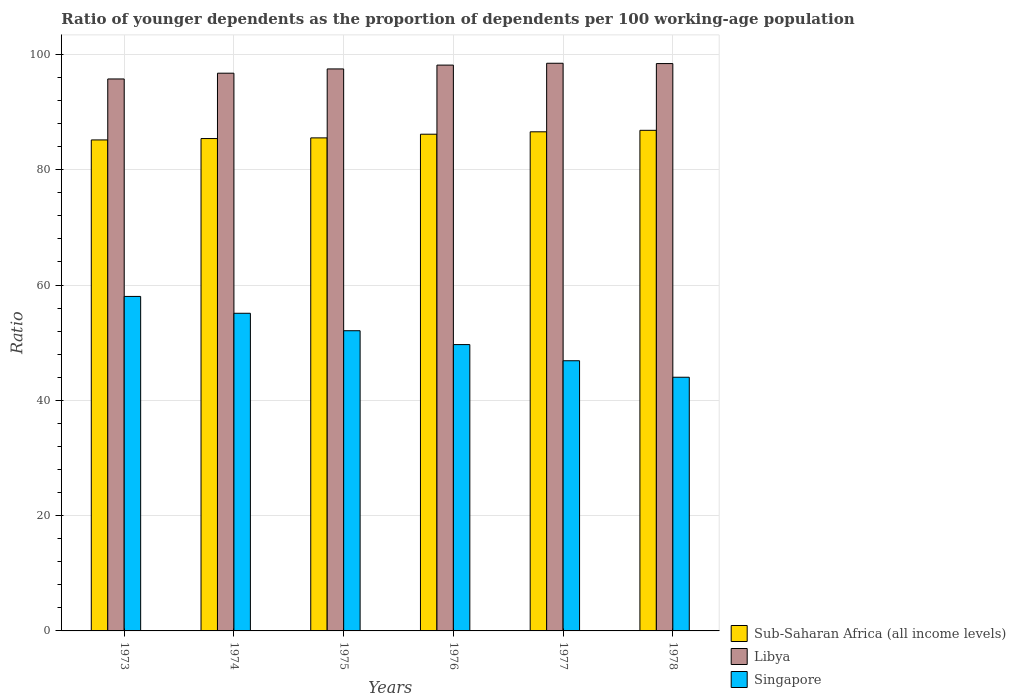How many groups of bars are there?
Offer a terse response. 6. Are the number of bars on each tick of the X-axis equal?
Your answer should be compact. Yes. How many bars are there on the 2nd tick from the left?
Your answer should be compact. 3. What is the label of the 2nd group of bars from the left?
Offer a terse response. 1974. In how many cases, is the number of bars for a given year not equal to the number of legend labels?
Ensure brevity in your answer.  0. What is the age dependency ratio(young) in Sub-Saharan Africa (all income levels) in 1976?
Offer a very short reply. 86.16. Across all years, what is the maximum age dependency ratio(young) in Sub-Saharan Africa (all income levels)?
Ensure brevity in your answer.  86.83. Across all years, what is the minimum age dependency ratio(young) in Libya?
Provide a short and direct response. 95.74. In which year was the age dependency ratio(young) in Sub-Saharan Africa (all income levels) maximum?
Provide a short and direct response. 1978. In which year was the age dependency ratio(young) in Singapore minimum?
Offer a very short reply. 1978. What is the total age dependency ratio(young) in Sub-Saharan Africa (all income levels) in the graph?
Offer a very short reply. 515.66. What is the difference between the age dependency ratio(young) in Libya in 1977 and that in 1978?
Your answer should be compact. 0.05. What is the difference between the age dependency ratio(young) in Libya in 1977 and the age dependency ratio(young) in Sub-Saharan Africa (all income levels) in 1975?
Your answer should be compact. 12.95. What is the average age dependency ratio(young) in Libya per year?
Keep it short and to the point. 97.5. In the year 1976, what is the difference between the age dependency ratio(young) in Singapore and age dependency ratio(young) in Libya?
Provide a short and direct response. -48.48. In how many years, is the age dependency ratio(young) in Singapore greater than 92?
Give a very brief answer. 0. What is the ratio of the age dependency ratio(young) in Singapore in 1977 to that in 1978?
Offer a very short reply. 1.07. What is the difference between the highest and the second highest age dependency ratio(young) in Sub-Saharan Africa (all income levels)?
Give a very brief answer. 0.26. What is the difference between the highest and the lowest age dependency ratio(young) in Sub-Saharan Africa (all income levels)?
Provide a short and direct response. 1.67. What does the 3rd bar from the left in 1973 represents?
Keep it short and to the point. Singapore. What does the 1st bar from the right in 1973 represents?
Your answer should be compact. Singapore. How many bars are there?
Give a very brief answer. 18. Are all the bars in the graph horizontal?
Offer a very short reply. No. How many years are there in the graph?
Your response must be concise. 6. Are the values on the major ticks of Y-axis written in scientific E-notation?
Give a very brief answer. No. Does the graph contain grids?
Your response must be concise. Yes. How many legend labels are there?
Make the answer very short. 3. How are the legend labels stacked?
Keep it short and to the point. Vertical. What is the title of the graph?
Your response must be concise. Ratio of younger dependents as the proportion of dependents per 100 working-age population. Does "Israel" appear as one of the legend labels in the graph?
Make the answer very short. No. What is the label or title of the Y-axis?
Your answer should be compact. Ratio. What is the Ratio in Sub-Saharan Africa (all income levels) in 1973?
Offer a very short reply. 85.17. What is the Ratio in Libya in 1973?
Make the answer very short. 95.74. What is the Ratio of Singapore in 1973?
Provide a succinct answer. 58.02. What is the Ratio of Sub-Saharan Africa (all income levels) in 1974?
Ensure brevity in your answer.  85.41. What is the Ratio of Libya in 1974?
Offer a very short reply. 96.74. What is the Ratio of Singapore in 1974?
Provide a short and direct response. 55.1. What is the Ratio in Sub-Saharan Africa (all income levels) in 1975?
Give a very brief answer. 85.52. What is the Ratio in Libya in 1975?
Provide a succinct answer. 97.48. What is the Ratio of Singapore in 1975?
Your response must be concise. 52.07. What is the Ratio of Sub-Saharan Africa (all income levels) in 1976?
Your response must be concise. 86.16. What is the Ratio in Libya in 1976?
Give a very brief answer. 98.15. What is the Ratio of Singapore in 1976?
Your answer should be compact. 49.67. What is the Ratio in Sub-Saharan Africa (all income levels) in 1977?
Your response must be concise. 86.57. What is the Ratio of Libya in 1977?
Provide a short and direct response. 98.47. What is the Ratio of Singapore in 1977?
Your answer should be very brief. 46.86. What is the Ratio in Sub-Saharan Africa (all income levels) in 1978?
Ensure brevity in your answer.  86.83. What is the Ratio in Libya in 1978?
Your answer should be very brief. 98.41. What is the Ratio in Singapore in 1978?
Make the answer very short. 44. Across all years, what is the maximum Ratio of Sub-Saharan Africa (all income levels)?
Provide a short and direct response. 86.83. Across all years, what is the maximum Ratio of Libya?
Offer a very short reply. 98.47. Across all years, what is the maximum Ratio of Singapore?
Your answer should be compact. 58.02. Across all years, what is the minimum Ratio in Sub-Saharan Africa (all income levels)?
Your response must be concise. 85.17. Across all years, what is the minimum Ratio in Libya?
Your response must be concise. 95.74. Across all years, what is the minimum Ratio of Singapore?
Your answer should be very brief. 44. What is the total Ratio in Sub-Saharan Africa (all income levels) in the graph?
Ensure brevity in your answer.  515.66. What is the total Ratio in Libya in the graph?
Give a very brief answer. 584.99. What is the total Ratio of Singapore in the graph?
Your response must be concise. 305.72. What is the difference between the Ratio of Sub-Saharan Africa (all income levels) in 1973 and that in 1974?
Provide a succinct answer. -0.24. What is the difference between the Ratio of Libya in 1973 and that in 1974?
Your answer should be very brief. -1. What is the difference between the Ratio in Singapore in 1973 and that in 1974?
Provide a succinct answer. 2.92. What is the difference between the Ratio of Sub-Saharan Africa (all income levels) in 1973 and that in 1975?
Make the answer very short. -0.35. What is the difference between the Ratio in Libya in 1973 and that in 1975?
Your answer should be compact. -1.74. What is the difference between the Ratio in Singapore in 1973 and that in 1975?
Provide a succinct answer. 5.95. What is the difference between the Ratio of Sub-Saharan Africa (all income levels) in 1973 and that in 1976?
Your answer should be very brief. -0.99. What is the difference between the Ratio of Libya in 1973 and that in 1976?
Offer a terse response. -2.4. What is the difference between the Ratio in Singapore in 1973 and that in 1976?
Your response must be concise. 8.35. What is the difference between the Ratio of Sub-Saharan Africa (all income levels) in 1973 and that in 1977?
Ensure brevity in your answer.  -1.41. What is the difference between the Ratio of Libya in 1973 and that in 1977?
Ensure brevity in your answer.  -2.72. What is the difference between the Ratio of Singapore in 1973 and that in 1977?
Offer a very short reply. 11.16. What is the difference between the Ratio in Sub-Saharan Africa (all income levels) in 1973 and that in 1978?
Make the answer very short. -1.67. What is the difference between the Ratio of Libya in 1973 and that in 1978?
Offer a terse response. -2.67. What is the difference between the Ratio in Singapore in 1973 and that in 1978?
Offer a terse response. 14.02. What is the difference between the Ratio of Sub-Saharan Africa (all income levels) in 1974 and that in 1975?
Provide a short and direct response. -0.11. What is the difference between the Ratio of Libya in 1974 and that in 1975?
Your response must be concise. -0.74. What is the difference between the Ratio in Singapore in 1974 and that in 1975?
Your answer should be very brief. 3.02. What is the difference between the Ratio of Sub-Saharan Africa (all income levels) in 1974 and that in 1976?
Provide a succinct answer. -0.75. What is the difference between the Ratio in Libya in 1974 and that in 1976?
Offer a terse response. -1.41. What is the difference between the Ratio in Singapore in 1974 and that in 1976?
Offer a very short reply. 5.43. What is the difference between the Ratio of Sub-Saharan Africa (all income levels) in 1974 and that in 1977?
Your response must be concise. -1.17. What is the difference between the Ratio of Libya in 1974 and that in 1977?
Make the answer very short. -1.72. What is the difference between the Ratio of Singapore in 1974 and that in 1977?
Provide a short and direct response. 8.23. What is the difference between the Ratio in Sub-Saharan Africa (all income levels) in 1974 and that in 1978?
Make the answer very short. -1.43. What is the difference between the Ratio in Libya in 1974 and that in 1978?
Provide a succinct answer. -1.67. What is the difference between the Ratio of Singapore in 1974 and that in 1978?
Provide a succinct answer. 11.1. What is the difference between the Ratio of Sub-Saharan Africa (all income levels) in 1975 and that in 1976?
Keep it short and to the point. -0.64. What is the difference between the Ratio in Libya in 1975 and that in 1976?
Provide a short and direct response. -0.66. What is the difference between the Ratio of Singapore in 1975 and that in 1976?
Ensure brevity in your answer.  2.41. What is the difference between the Ratio of Sub-Saharan Africa (all income levels) in 1975 and that in 1977?
Give a very brief answer. -1.05. What is the difference between the Ratio in Libya in 1975 and that in 1977?
Your response must be concise. -0.98. What is the difference between the Ratio of Singapore in 1975 and that in 1977?
Offer a very short reply. 5.21. What is the difference between the Ratio in Sub-Saharan Africa (all income levels) in 1975 and that in 1978?
Your answer should be very brief. -1.31. What is the difference between the Ratio in Libya in 1975 and that in 1978?
Provide a succinct answer. -0.93. What is the difference between the Ratio in Singapore in 1975 and that in 1978?
Your answer should be very brief. 8.07. What is the difference between the Ratio in Sub-Saharan Africa (all income levels) in 1976 and that in 1977?
Keep it short and to the point. -0.42. What is the difference between the Ratio of Libya in 1976 and that in 1977?
Make the answer very short. -0.32. What is the difference between the Ratio in Singapore in 1976 and that in 1977?
Ensure brevity in your answer.  2.8. What is the difference between the Ratio of Sub-Saharan Africa (all income levels) in 1976 and that in 1978?
Make the answer very short. -0.67. What is the difference between the Ratio in Libya in 1976 and that in 1978?
Offer a terse response. -0.27. What is the difference between the Ratio of Singapore in 1976 and that in 1978?
Your answer should be very brief. 5.66. What is the difference between the Ratio of Sub-Saharan Africa (all income levels) in 1977 and that in 1978?
Ensure brevity in your answer.  -0.26. What is the difference between the Ratio in Libya in 1977 and that in 1978?
Offer a very short reply. 0.05. What is the difference between the Ratio in Singapore in 1977 and that in 1978?
Ensure brevity in your answer.  2.86. What is the difference between the Ratio in Sub-Saharan Africa (all income levels) in 1973 and the Ratio in Libya in 1974?
Your response must be concise. -11.57. What is the difference between the Ratio in Sub-Saharan Africa (all income levels) in 1973 and the Ratio in Singapore in 1974?
Provide a succinct answer. 30.07. What is the difference between the Ratio in Libya in 1973 and the Ratio in Singapore in 1974?
Your answer should be very brief. 40.64. What is the difference between the Ratio of Sub-Saharan Africa (all income levels) in 1973 and the Ratio of Libya in 1975?
Provide a succinct answer. -12.31. What is the difference between the Ratio in Sub-Saharan Africa (all income levels) in 1973 and the Ratio in Singapore in 1975?
Your response must be concise. 33.09. What is the difference between the Ratio of Libya in 1973 and the Ratio of Singapore in 1975?
Provide a succinct answer. 43.67. What is the difference between the Ratio of Sub-Saharan Africa (all income levels) in 1973 and the Ratio of Libya in 1976?
Your response must be concise. -12.98. What is the difference between the Ratio in Sub-Saharan Africa (all income levels) in 1973 and the Ratio in Singapore in 1976?
Your answer should be compact. 35.5. What is the difference between the Ratio of Libya in 1973 and the Ratio of Singapore in 1976?
Make the answer very short. 46.07. What is the difference between the Ratio of Sub-Saharan Africa (all income levels) in 1973 and the Ratio of Libya in 1977?
Your response must be concise. -13.3. What is the difference between the Ratio of Sub-Saharan Africa (all income levels) in 1973 and the Ratio of Singapore in 1977?
Offer a very short reply. 38.3. What is the difference between the Ratio of Libya in 1973 and the Ratio of Singapore in 1977?
Ensure brevity in your answer.  48.88. What is the difference between the Ratio of Sub-Saharan Africa (all income levels) in 1973 and the Ratio of Libya in 1978?
Your answer should be very brief. -13.24. What is the difference between the Ratio in Sub-Saharan Africa (all income levels) in 1973 and the Ratio in Singapore in 1978?
Ensure brevity in your answer.  41.17. What is the difference between the Ratio in Libya in 1973 and the Ratio in Singapore in 1978?
Keep it short and to the point. 51.74. What is the difference between the Ratio of Sub-Saharan Africa (all income levels) in 1974 and the Ratio of Libya in 1975?
Your response must be concise. -12.08. What is the difference between the Ratio in Sub-Saharan Africa (all income levels) in 1974 and the Ratio in Singapore in 1975?
Your response must be concise. 33.33. What is the difference between the Ratio of Libya in 1974 and the Ratio of Singapore in 1975?
Offer a terse response. 44.67. What is the difference between the Ratio of Sub-Saharan Africa (all income levels) in 1974 and the Ratio of Libya in 1976?
Give a very brief answer. -12.74. What is the difference between the Ratio of Sub-Saharan Africa (all income levels) in 1974 and the Ratio of Singapore in 1976?
Give a very brief answer. 35.74. What is the difference between the Ratio of Libya in 1974 and the Ratio of Singapore in 1976?
Provide a succinct answer. 47.07. What is the difference between the Ratio of Sub-Saharan Africa (all income levels) in 1974 and the Ratio of Libya in 1977?
Make the answer very short. -13.06. What is the difference between the Ratio in Sub-Saharan Africa (all income levels) in 1974 and the Ratio in Singapore in 1977?
Provide a succinct answer. 38.54. What is the difference between the Ratio of Libya in 1974 and the Ratio of Singapore in 1977?
Provide a succinct answer. 49.88. What is the difference between the Ratio in Sub-Saharan Africa (all income levels) in 1974 and the Ratio in Libya in 1978?
Offer a very short reply. -13.01. What is the difference between the Ratio in Sub-Saharan Africa (all income levels) in 1974 and the Ratio in Singapore in 1978?
Provide a short and direct response. 41.4. What is the difference between the Ratio in Libya in 1974 and the Ratio in Singapore in 1978?
Provide a succinct answer. 52.74. What is the difference between the Ratio of Sub-Saharan Africa (all income levels) in 1975 and the Ratio of Libya in 1976?
Ensure brevity in your answer.  -12.63. What is the difference between the Ratio of Sub-Saharan Africa (all income levels) in 1975 and the Ratio of Singapore in 1976?
Give a very brief answer. 35.85. What is the difference between the Ratio of Libya in 1975 and the Ratio of Singapore in 1976?
Make the answer very short. 47.81. What is the difference between the Ratio of Sub-Saharan Africa (all income levels) in 1975 and the Ratio of Libya in 1977?
Make the answer very short. -12.95. What is the difference between the Ratio in Sub-Saharan Africa (all income levels) in 1975 and the Ratio in Singapore in 1977?
Provide a succinct answer. 38.66. What is the difference between the Ratio in Libya in 1975 and the Ratio in Singapore in 1977?
Ensure brevity in your answer.  50.62. What is the difference between the Ratio in Sub-Saharan Africa (all income levels) in 1975 and the Ratio in Libya in 1978?
Ensure brevity in your answer.  -12.89. What is the difference between the Ratio in Sub-Saharan Africa (all income levels) in 1975 and the Ratio in Singapore in 1978?
Your answer should be very brief. 41.52. What is the difference between the Ratio of Libya in 1975 and the Ratio of Singapore in 1978?
Keep it short and to the point. 53.48. What is the difference between the Ratio of Sub-Saharan Africa (all income levels) in 1976 and the Ratio of Libya in 1977?
Provide a short and direct response. -12.31. What is the difference between the Ratio of Sub-Saharan Africa (all income levels) in 1976 and the Ratio of Singapore in 1977?
Provide a short and direct response. 39.3. What is the difference between the Ratio of Libya in 1976 and the Ratio of Singapore in 1977?
Your answer should be very brief. 51.28. What is the difference between the Ratio in Sub-Saharan Africa (all income levels) in 1976 and the Ratio in Libya in 1978?
Make the answer very short. -12.25. What is the difference between the Ratio of Sub-Saharan Africa (all income levels) in 1976 and the Ratio of Singapore in 1978?
Ensure brevity in your answer.  42.16. What is the difference between the Ratio in Libya in 1976 and the Ratio in Singapore in 1978?
Provide a short and direct response. 54.14. What is the difference between the Ratio in Sub-Saharan Africa (all income levels) in 1977 and the Ratio in Libya in 1978?
Your response must be concise. -11.84. What is the difference between the Ratio in Sub-Saharan Africa (all income levels) in 1977 and the Ratio in Singapore in 1978?
Your response must be concise. 42.57. What is the difference between the Ratio in Libya in 1977 and the Ratio in Singapore in 1978?
Provide a succinct answer. 54.46. What is the average Ratio in Sub-Saharan Africa (all income levels) per year?
Make the answer very short. 85.94. What is the average Ratio in Libya per year?
Ensure brevity in your answer.  97.5. What is the average Ratio of Singapore per year?
Provide a succinct answer. 50.95. In the year 1973, what is the difference between the Ratio in Sub-Saharan Africa (all income levels) and Ratio in Libya?
Your response must be concise. -10.57. In the year 1973, what is the difference between the Ratio in Sub-Saharan Africa (all income levels) and Ratio in Singapore?
Provide a succinct answer. 27.15. In the year 1973, what is the difference between the Ratio in Libya and Ratio in Singapore?
Your answer should be compact. 37.72. In the year 1974, what is the difference between the Ratio of Sub-Saharan Africa (all income levels) and Ratio of Libya?
Your answer should be compact. -11.34. In the year 1974, what is the difference between the Ratio of Sub-Saharan Africa (all income levels) and Ratio of Singapore?
Make the answer very short. 30.31. In the year 1974, what is the difference between the Ratio of Libya and Ratio of Singapore?
Offer a terse response. 41.64. In the year 1975, what is the difference between the Ratio in Sub-Saharan Africa (all income levels) and Ratio in Libya?
Provide a short and direct response. -11.96. In the year 1975, what is the difference between the Ratio in Sub-Saharan Africa (all income levels) and Ratio in Singapore?
Make the answer very short. 33.45. In the year 1975, what is the difference between the Ratio of Libya and Ratio of Singapore?
Offer a terse response. 45.41. In the year 1976, what is the difference between the Ratio of Sub-Saharan Africa (all income levels) and Ratio of Libya?
Your response must be concise. -11.99. In the year 1976, what is the difference between the Ratio in Sub-Saharan Africa (all income levels) and Ratio in Singapore?
Offer a terse response. 36.49. In the year 1976, what is the difference between the Ratio in Libya and Ratio in Singapore?
Offer a terse response. 48.48. In the year 1977, what is the difference between the Ratio of Sub-Saharan Africa (all income levels) and Ratio of Libya?
Make the answer very short. -11.89. In the year 1977, what is the difference between the Ratio in Sub-Saharan Africa (all income levels) and Ratio in Singapore?
Provide a succinct answer. 39.71. In the year 1977, what is the difference between the Ratio of Libya and Ratio of Singapore?
Ensure brevity in your answer.  51.6. In the year 1978, what is the difference between the Ratio in Sub-Saharan Africa (all income levels) and Ratio in Libya?
Provide a succinct answer. -11.58. In the year 1978, what is the difference between the Ratio of Sub-Saharan Africa (all income levels) and Ratio of Singapore?
Offer a terse response. 42.83. In the year 1978, what is the difference between the Ratio of Libya and Ratio of Singapore?
Give a very brief answer. 54.41. What is the ratio of the Ratio in Libya in 1973 to that in 1974?
Keep it short and to the point. 0.99. What is the ratio of the Ratio of Singapore in 1973 to that in 1974?
Make the answer very short. 1.05. What is the ratio of the Ratio in Libya in 1973 to that in 1975?
Offer a terse response. 0.98. What is the ratio of the Ratio in Singapore in 1973 to that in 1975?
Your answer should be compact. 1.11. What is the ratio of the Ratio of Libya in 1973 to that in 1976?
Your answer should be compact. 0.98. What is the ratio of the Ratio in Singapore in 1973 to that in 1976?
Keep it short and to the point. 1.17. What is the ratio of the Ratio in Sub-Saharan Africa (all income levels) in 1973 to that in 1977?
Your answer should be very brief. 0.98. What is the ratio of the Ratio in Libya in 1973 to that in 1977?
Your answer should be compact. 0.97. What is the ratio of the Ratio in Singapore in 1973 to that in 1977?
Your answer should be compact. 1.24. What is the ratio of the Ratio of Sub-Saharan Africa (all income levels) in 1973 to that in 1978?
Provide a succinct answer. 0.98. What is the ratio of the Ratio of Libya in 1973 to that in 1978?
Provide a short and direct response. 0.97. What is the ratio of the Ratio in Singapore in 1973 to that in 1978?
Ensure brevity in your answer.  1.32. What is the ratio of the Ratio of Singapore in 1974 to that in 1975?
Ensure brevity in your answer.  1.06. What is the ratio of the Ratio in Sub-Saharan Africa (all income levels) in 1974 to that in 1976?
Your answer should be very brief. 0.99. What is the ratio of the Ratio of Libya in 1974 to that in 1976?
Make the answer very short. 0.99. What is the ratio of the Ratio in Singapore in 1974 to that in 1976?
Give a very brief answer. 1.11. What is the ratio of the Ratio in Sub-Saharan Africa (all income levels) in 1974 to that in 1977?
Give a very brief answer. 0.99. What is the ratio of the Ratio in Libya in 1974 to that in 1977?
Your answer should be very brief. 0.98. What is the ratio of the Ratio of Singapore in 1974 to that in 1977?
Keep it short and to the point. 1.18. What is the ratio of the Ratio of Sub-Saharan Africa (all income levels) in 1974 to that in 1978?
Offer a very short reply. 0.98. What is the ratio of the Ratio of Libya in 1974 to that in 1978?
Make the answer very short. 0.98. What is the ratio of the Ratio in Singapore in 1974 to that in 1978?
Your answer should be compact. 1.25. What is the ratio of the Ratio of Sub-Saharan Africa (all income levels) in 1975 to that in 1976?
Keep it short and to the point. 0.99. What is the ratio of the Ratio of Singapore in 1975 to that in 1976?
Your answer should be compact. 1.05. What is the ratio of the Ratio in Sub-Saharan Africa (all income levels) in 1975 to that in 1977?
Ensure brevity in your answer.  0.99. What is the ratio of the Ratio in Libya in 1975 to that in 1977?
Keep it short and to the point. 0.99. What is the ratio of the Ratio in Sub-Saharan Africa (all income levels) in 1975 to that in 1978?
Make the answer very short. 0.98. What is the ratio of the Ratio in Singapore in 1975 to that in 1978?
Your answer should be compact. 1.18. What is the ratio of the Ratio of Libya in 1976 to that in 1977?
Provide a short and direct response. 1. What is the ratio of the Ratio of Singapore in 1976 to that in 1977?
Provide a succinct answer. 1.06. What is the ratio of the Ratio of Libya in 1976 to that in 1978?
Your answer should be very brief. 1. What is the ratio of the Ratio of Singapore in 1976 to that in 1978?
Provide a short and direct response. 1.13. What is the ratio of the Ratio in Sub-Saharan Africa (all income levels) in 1977 to that in 1978?
Offer a terse response. 1. What is the ratio of the Ratio of Libya in 1977 to that in 1978?
Make the answer very short. 1. What is the ratio of the Ratio of Singapore in 1977 to that in 1978?
Make the answer very short. 1.06. What is the difference between the highest and the second highest Ratio of Sub-Saharan Africa (all income levels)?
Provide a succinct answer. 0.26. What is the difference between the highest and the second highest Ratio of Libya?
Provide a short and direct response. 0.05. What is the difference between the highest and the second highest Ratio in Singapore?
Give a very brief answer. 2.92. What is the difference between the highest and the lowest Ratio of Sub-Saharan Africa (all income levels)?
Your answer should be compact. 1.67. What is the difference between the highest and the lowest Ratio in Libya?
Your answer should be very brief. 2.72. What is the difference between the highest and the lowest Ratio of Singapore?
Make the answer very short. 14.02. 